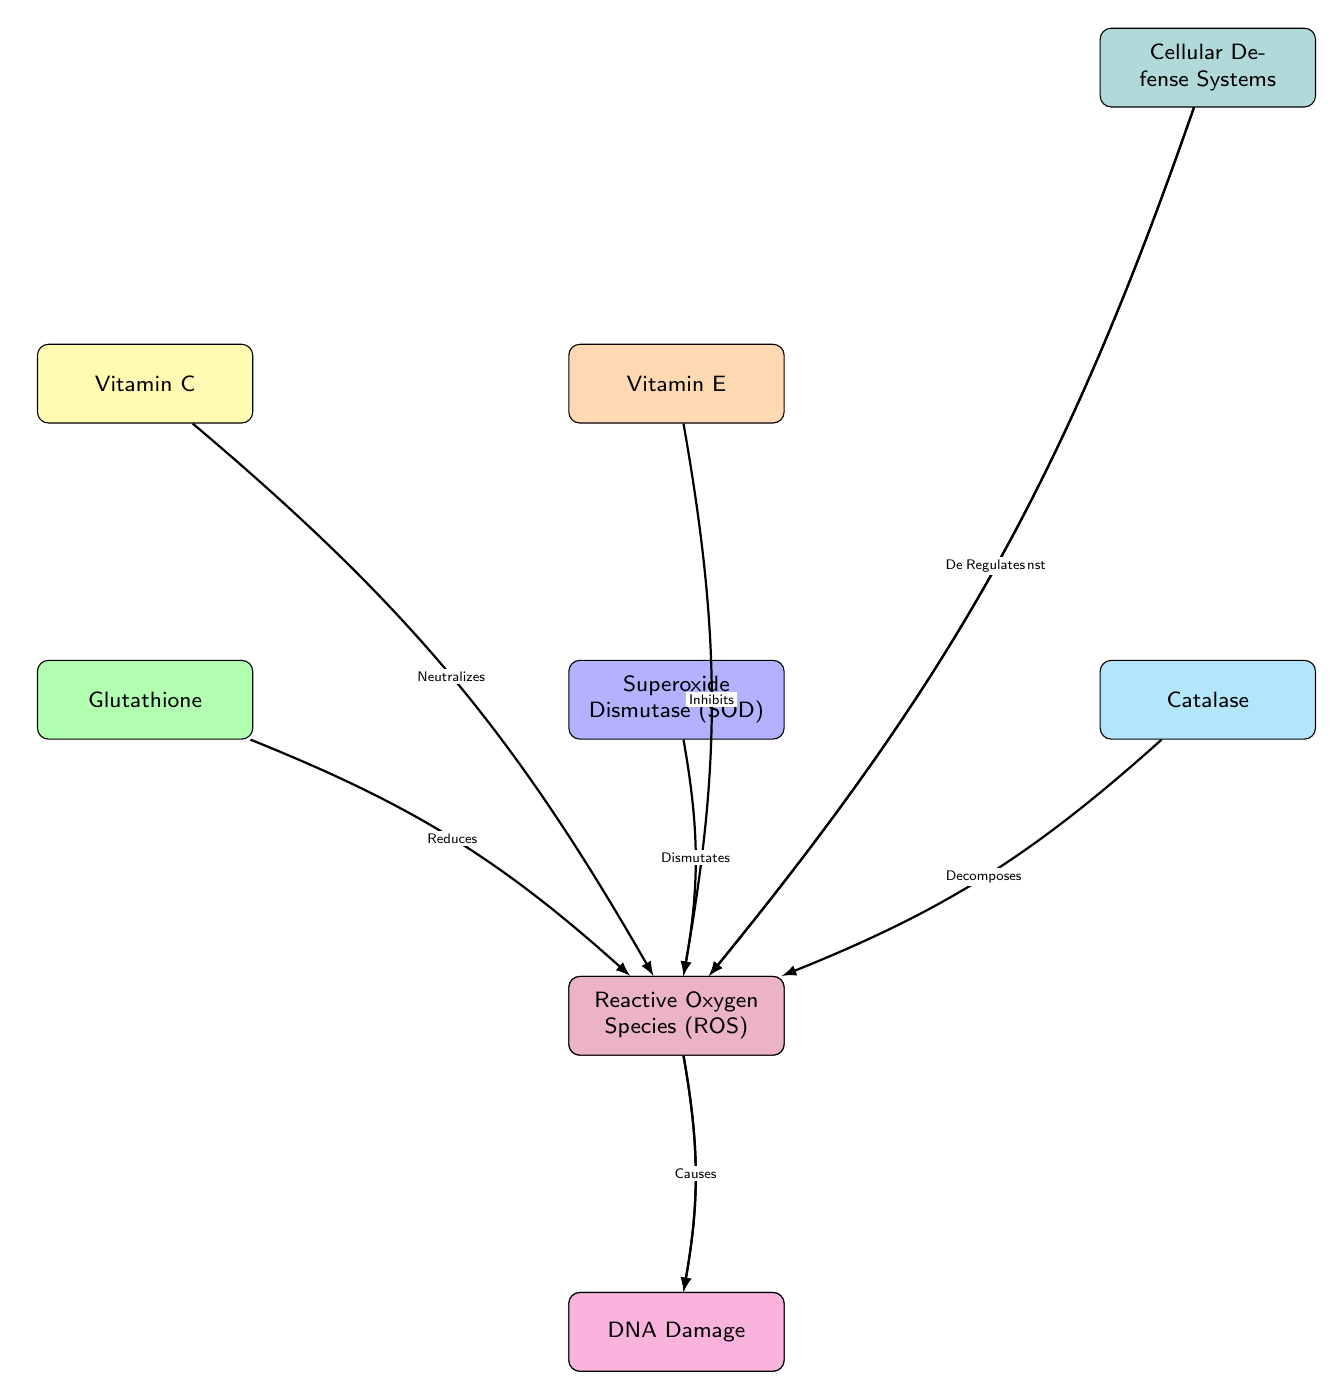What are the main antioxidants represented in the diagram? The diagram lists Vitamin C, Vitamin E, Glutathione, Superoxide Dismutase (SOD), and Catalase as the main antioxidants, displayed in the upper part of the diagram.
Answer: Vitamin C, Vitamin E, Glutathione, Superoxide Dismutase (SOD), Catalase How many cellular defense systems are shown? The diagram highlights one node labeled "Cellular Defense Systems," indicating there is a single representation of these defense mechanisms.
Answer: 1 What role does Vitamin E play in relation to free radicals? The diagram indicates that Vitamin E "Inhibits" free radicals, which is the specific relationship connecting Vitamin E to free radicals.
Answer: Inhibits Which element does Superoxide Dismutase (SOD) interact with? The diagram shows that Superoxide Dismutase (SOD) "Dismutates" Reactive Oxygen Species (ROS), indicating the specific interaction.
Answer: Dismutates What effect does Reactive Oxygen Species (ROS) have on DNA? The diagram states that Reactive Oxygen Species (ROS) "Causes" DNA Damage, revealing the negative impact associated with ROS.
Answer: Causes How does Cellular Defense Systems relate to Reactive Oxygen Species (ROS)? The diagram illustrates that Cellular Defense Systems "Regulates" Reactive Oxygen Species (ROS), indicating a protective interaction.
Answer: Regulates What is the outcome of the interaction between Reactive Oxygen Species (ROS) and the cellular structures? The diagram outlines two outcomes: ROS "Induces" Lipid Peroxidation and "Causes" DNA Damage, both negative consequences of ROS interactions.
Answer: Induces, Causes Which antioxidant reduces free radicals? The diagram indicates that Glutathione "Reduces" free radicals, showing its effectiveness in this regard.
Answer: Reduces How many edges connect Vitamin C to other components in the diagram? Vitamin C is connected to one edge with the label "Neutralizes" to free radicals, showing its direct action.
Answer: 1 